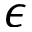<formula> <loc_0><loc_0><loc_500><loc_500>\epsilon</formula> 